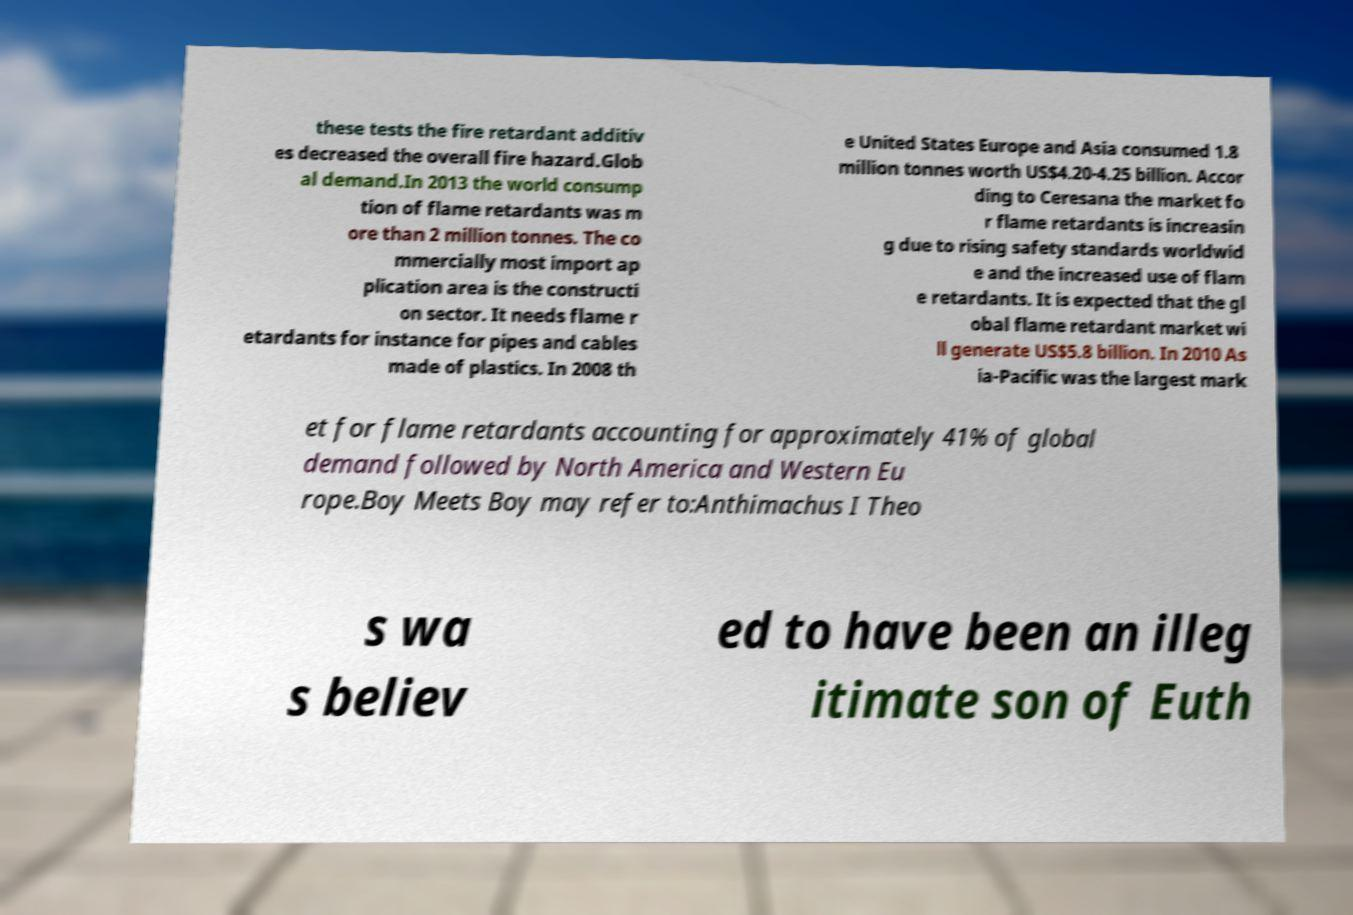For documentation purposes, I need the text within this image transcribed. Could you provide that? these tests the fire retardant additiv es decreased the overall fire hazard.Glob al demand.In 2013 the world consump tion of flame retardants was m ore than 2 million tonnes. The co mmercially most import ap plication area is the constructi on sector. It needs flame r etardants for instance for pipes and cables made of plastics. In 2008 th e United States Europe and Asia consumed 1.8 million tonnes worth US$4.20-4.25 billion. Accor ding to Ceresana the market fo r flame retardants is increasin g due to rising safety standards worldwid e and the increased use of flam e retardants. It is expected that the gl obal flame retardant market wi ll generate US$5.8 billion. In 2010 As ia-Pacific was the largest mark et for flame retardants accounting for approximately 41% of global demand followed by North America and Western Eu rope.Boy Meets Boy may refer to:Anthimachus I Theo s wa s believ ed to have been an illeg itimate son of Euth 